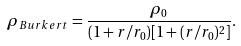Convert formula to latex. <formula><loc_0><loc_0><loc_500><loc_500>\rho _ { B u r k e r t } = \frac { \rho _ { 0 } } { ( 1 + r / r _ { 0 } ) [ 1 + ( r / r _ { 0 } ) ^ { 2 } ] } .</formula> 